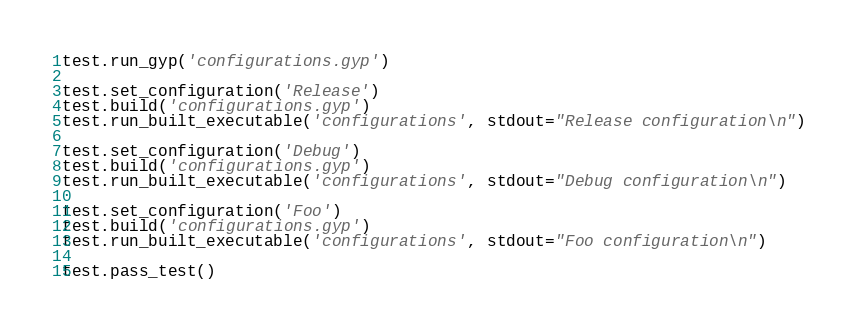<code> <loc_0><loc_0><loc_500><loc_500><_Python_>test.run_gyp('configurations.gyp')

test.set_configuration('Release')
test.build('configurations.gyp')
test.run_built_executable('configurations', stdout="Release configuration\n")

test.set_configuration('Debug')
test.build('configurations.gyp')
test.run_built_executable('configurations', stdout="Debug configuration\n")

test.set_configuration('Foo')
test.build('configurations.gyp')
test.run_built_executable('configurations', stdout="Foo configuration\n")

test.pass_test()
</code> 